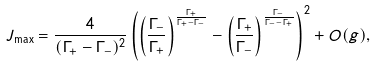Convert formula to latex. <formula><loc_0><loc_0><loc_500><loc_500>J _ { \max } = \frac { 4 } { ( \Gamma _ { + } - \Gamma _ { - } ) ^ { 2 } } \left ( \left ( \frac { \Gamma _ { - } } { \Gamma _ { + } } \right ) ^ { \frac { \Gamma _ { + } } { \Gamma _ { + } - \Gamma _ { - } } } - \left ( \frac { \Gamma _ { + } } { \Gamma _ { - } } \right ) ^ { \frac { \Gamma _ { - } } { \Gamma _ { - } - \Gamma _ { + } } } \right ) ^ { 2 } + O ( g ) ,</formula> 